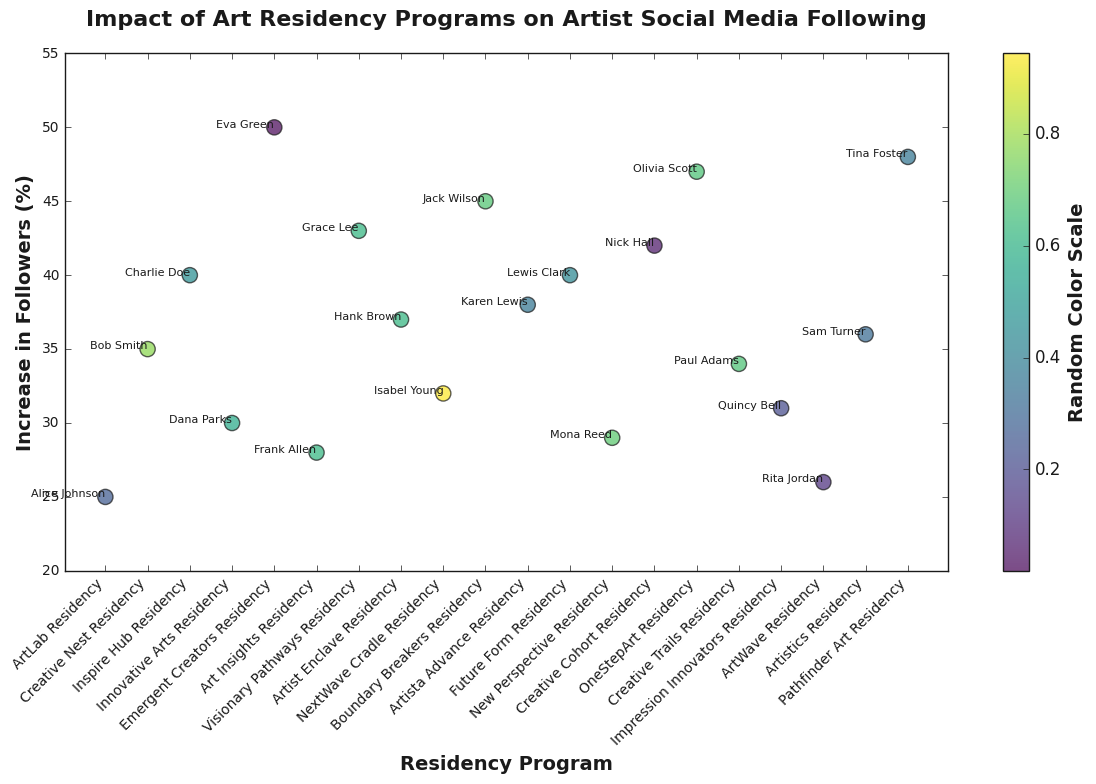What was the highest increase in followers and which residency program did it come from? By examining the scatter plot for the point with the highest y-value, we find that the highest increase in followers is 50%. This point corresponds to the "Emergent Creators Residency" program.
Answer: 50%, Emergent Creators Residency Which residency program had the smallest percentage increase in followers and by how much? By looking for the point with the lowest y-value on the scatter plot, we see that the smallest increase in followers is 25%, which corresponds to the "ArtLab Residency" program.
Answer: 25%, ArtLab Residency What is the average increase in followers across all residency programs? To calculate the average increase, we sum all the increase percentages and divide by the number of data points: (25 + 35 + 40 + 30 + 50 + 28 + 43 + 37 + 32 + 45 + 38 + 40 + 29 + 42 + 47 + 34 + 31 + 26 + 36 + 48) / 20 = 37.25
Answer: 37.25% How many residency programs resulted in a followers increase greater than 40%? By counting the points above the 40% mark on the y-axis of the scatter plot, we find that there are 8 such programs.
Answer: 8 Compare the increase in followers for "Creative Cohort Residency" and "Inspire Hub Residency". Which one had a higher increase and by how much? The scatter plot shows that "Creative Cohort Residency" had a 42% increase while "Inspire Hub Residency" had a 40% increase. The difference is 42% - 40% = 2%.
Answer: Creative Cohort Residency, 2% Is there any residency program that resulted in an increase between 32% and 35%? If yes, name them. By examining points between 32% and 35% on the y-axis, we find that "Artist Enclave Residency" (37%) is just above but does not fall between 32% and 35%. No other programs fall strictly within this range in the visual aid.
Answer: No What is the difference in the increase in followers between the highest and lowest performing residency programs? The highest increase is 50% from "Emergent Creators Residency" and the lowest is 25% from "ArtLab Residency". The difference is 50% - 25% = 25%.
Answer: 25% What can be said about the general trend of residency programs and increase in followers, based on the scatter plot? The scatter plot reveals that most residency programs have an increase in followers ranging from 25% to 50%, with no specific pattern or trend in how different programs are clustered on the y-axis.
Answer: Varied range between 25%-50% Are there more residency programs resulting in over 40% increase or under 40% increase in followers? By counting the points above and below the 40% mark on the y-axis, we see there are 8 programs above 40% and 12 programs below 40%.
Answer: Under 40%, 12 programs 